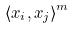<formula> <loc_0><loc_0><loc_500><loc_500>\langle x _ { i } , x _ { j } \rangle ^ { m }</formula> 